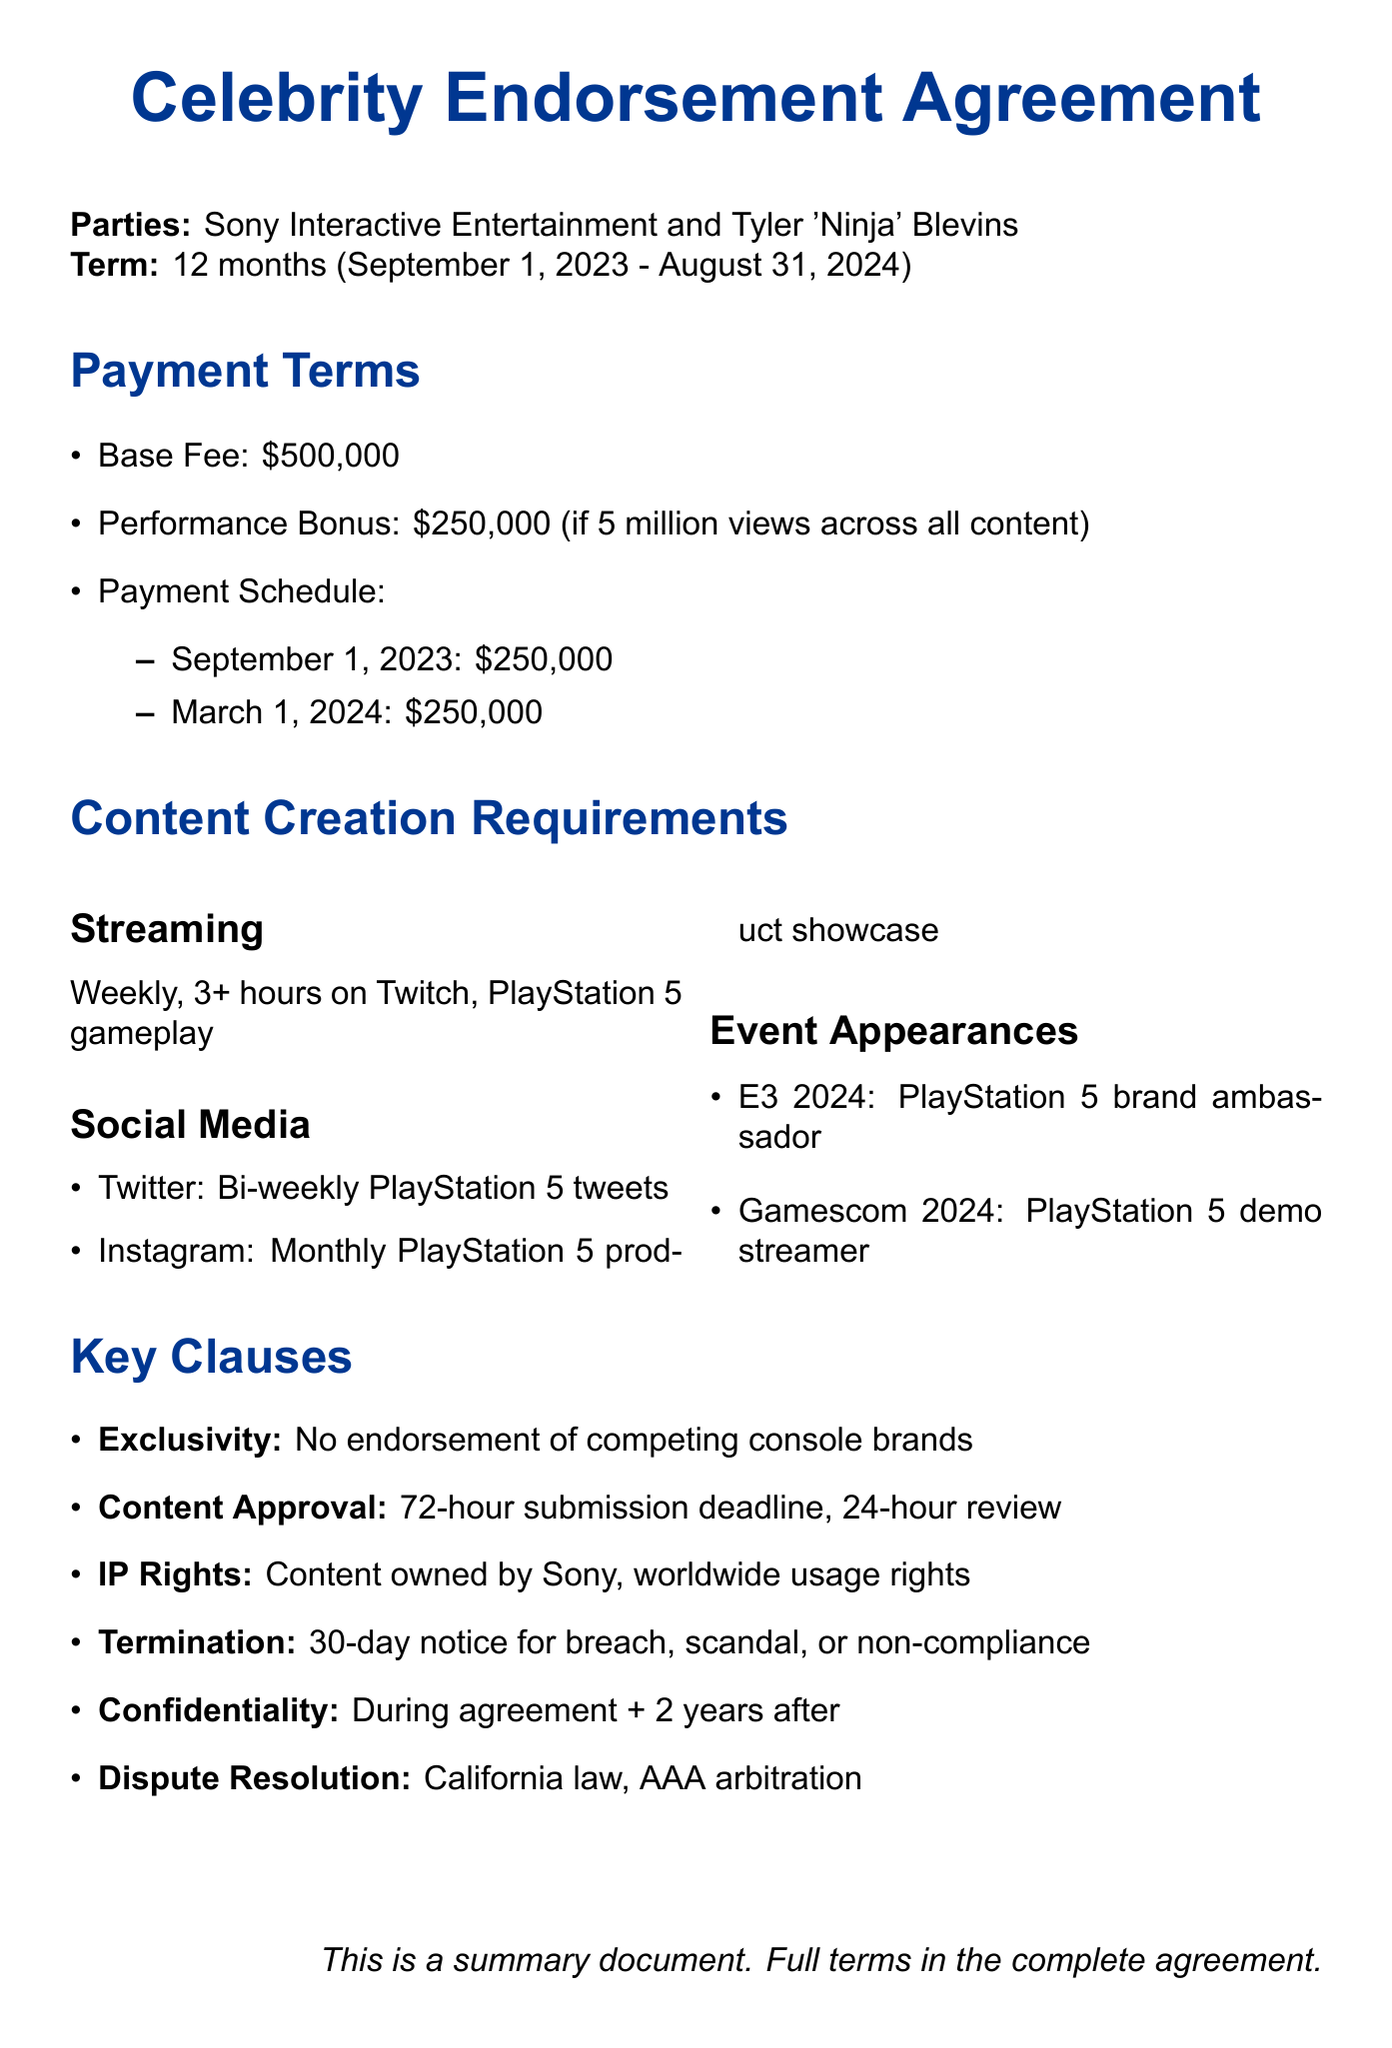What is the total base fee for the endorsement? The base fee for the endorsement is listed in the payment terms section of the document as $500,000.
Answer: $500,000 What are the performance bonus requirements? The performance bonus is contingent on achieving 5 million views across all content, resulting in an additional $250,000.
Answer: 5 million views What is the duration of the agreement? The agreement spans from the start date to the end date specified in the agreement details section, which is 12 months.
Answer: 12 months How often is the celebrity required to stream? The streaming obligations state that the celebrity must stream weekly for a minimum duration specified in the document.
Answer: Weekly Which platforms are included for the social media posts? The document specifies Twitter and Instagram as the platforms for social media posts, along with their respective frequencies.
Answer: Twitter, Instagram What is the notice period for termination? The termination clause outlines a notice period required for termination, which is explicitly stated in the document.
Answer: 30 days What role will the celebrity have at E3 2024? The document describes the celebrity's role at E3 2024 in the event appearances section as a "PlayStation 5 brand ambassador."
Answer: PlayStation 5 brand ambassador What is the review period for content approval? The content approval process includes a review period specified in the document.
Answer: 24 hours What is the scope of the confidentiality agreement? The confidentiality agreement specifies the scope as covering all non-public information related to PlayStation 5 and upcoming releases.
Answer: All non-public information related to PlayStation 5 and upcoming releases 